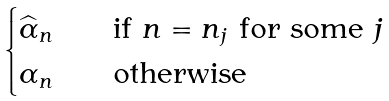<formula> <loc_0><loc_0><loc_500><loc_500>\begin{cases} \widehat { \alpha } _ { n } \quad & \text {if $n=n_{j}$ for some $j$} \\ \alpha _ { n } \quad & \text {otherwise} \end{cases}</formula> 